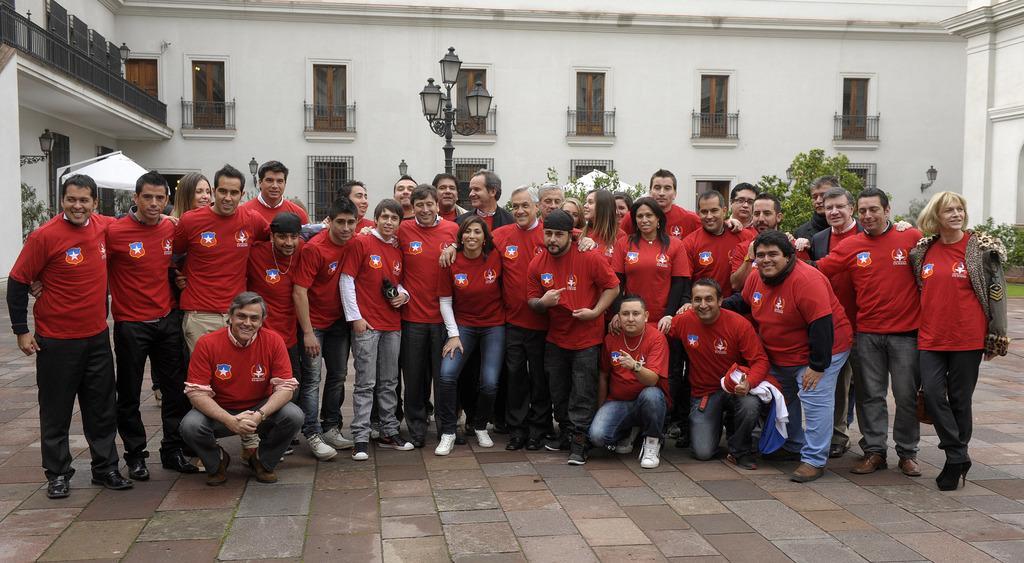Can you describe this image briefly? In this image we can see group of persons standing on the ground. One person is holding a microphone in his hand. One woman is wearing a jacket. In the background, we can see light pole, a building with windows and metal railing and some trees. 